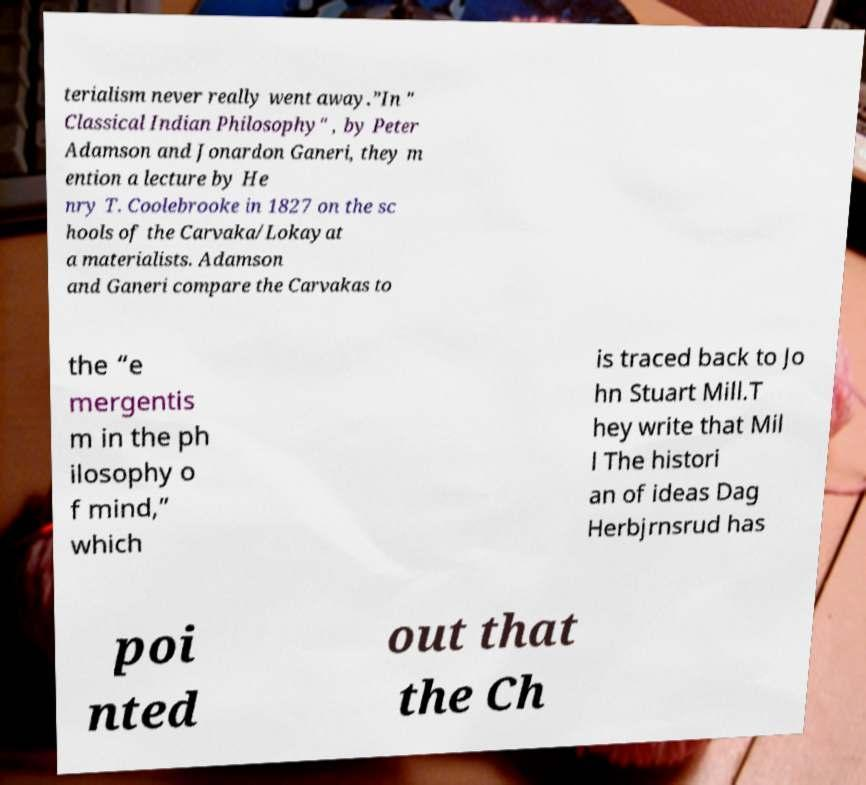Please read and relay the text visible in this image. What does it say? terialism never really went away.”In " Classical Indian Philosophy" , by Peter Adamson and Jonardon Ganeri, they m ention a lecture by He nry T. Coolebrooke in 1827 on the sc hools of the Carvaka/Lokayat a materialists. Adamson and Ganeri compare the Carvakas to the “e mergentis m in the ph ilosophy o f mind,” which is traced back to Jo hn Stuart Mill.T hey write that Mil l The histori an of ideas Dag Herbjrnsrud has poi nted out that the Ch 